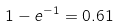<formula> <loc_0><loc_0><loc_500><loc_500>1 - e ^ { - 1 } = 0 . 6 1</formula> 